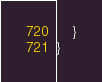<code> <loc_0><loc_0><loc_500><loc_500><_Kotlin_>    }
}
</code> 